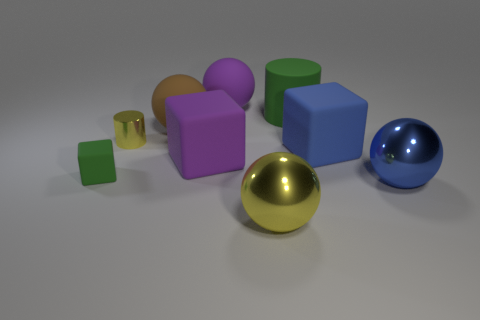Add 1 big rubber balls. How many objects exist? 10 Subtract all purple matte spheres. Subtract all large purple matte blocks. How many objects are left? 7 Add 2 brown rubber objects. How many brown rubber objects are left? 3 Add 4 shiny cylinders. How many shiny cylinders exist? 5 Subtract all yellow cylinders. How many cylinders are left? 1 Subtract all big brown matte spheres. How many spheres are left? 3 Subtract 1 brown balls. How many objects are left? 8 Subtract all cylinders. How many objects are left? 7 Subtract 2 blocks. How many blocks are left? 1 Subtract all blue blocks. Subtract all cyan balls. How many blocks are left? 2 